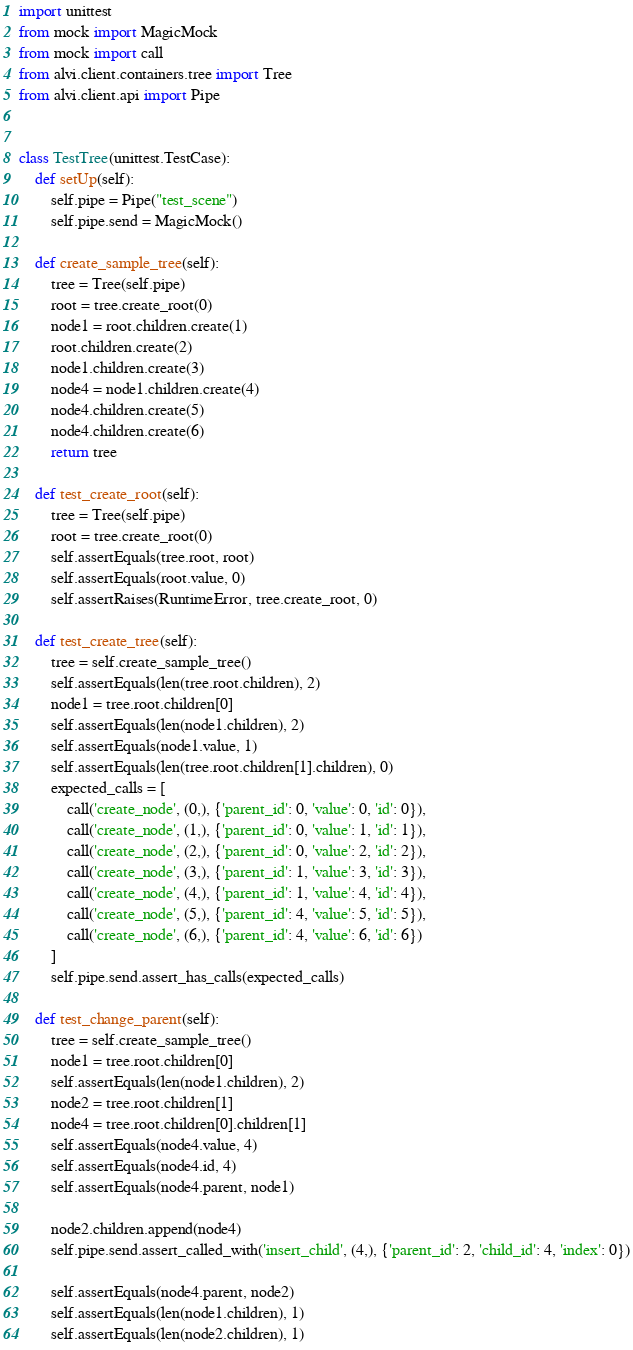<code> <loc_0><loc_0><loc_500><loc_500><_Python_>import unittest
from mock import MagicMock
from mock import call
from alvi.client.containers.tree import Tree
from alvi.client.api import Pipe


class TestTree(unittest.TestCase):
    def setUp(self):
        self.pipe = Pipe("test_scene")
        self.pipe.send = MagicMock()

    def create_sample_tree(self):
        tree = Tree(self.pipe)
        root = tree.create_root(0)
        node1 = root.children.create(1)
        root.children.create(2)
        node1.children.create(3)
        node4 = node1.children.create(4)
        node4.children.create(5)
        node4.children.create(6)
        return tree

    def test_create_root(self):
        tree = Tree(self.pipe)
        root = tree.create_root(0)
        self.assertEquals(tree.root, root)
        self.assertEquals(root.value, 0)
        self.assertRaises(RuntimeError, tree.create_root, 0)

    def test_create_tree(self):
        tree = self.create_sample_tree()
        self.assertEquals(len(tree.root.children), 2)
        node1 = tree.root.children[0]
        self.assertEquals(len(node1.children), 2)
        self.assertEquals(node1.value, 1)
        self.assertEquals(len(tree.root.children[1].children), 0)
        expected_calls = [
            call('create_node', (0,), {'parent_id': 0, 'value': 0, 'id': 0}),
            call('create_node', (1,), {'parent_id': 0, 'value': 1, 'id': 1}),
            call('create_node', (2,), {'parent_id': 0, 'value': 2, 'id': 2}),
            call('create_node', (3,), {'parent_id': 1, 'value': 3, 'id': 3}),
            call('create_node', (4,), {'parent_id': 1, 'value': 4, 'id': 4}),
            call('create_node', (5,), {'parent_id': 4, 'value': 5, 'id': 5}),
            call('create_node', (6,), {'parent_id': 4, 'value': 6, 'id': 6})
        ]
        self.pipe.send.assert_has_calls(expected_calls)

    def test_change_parent(self):
        tree = self.create_sample_tree()
        node1 = tree.root.children[0]
        self.assertEquals(len(node1.children), 2)
        node2 = tree.root.children[1]
        node4 = tree.root.children[0].children[1]
        self.assertEquals(node4.value, 4)
        self.assertEquals(node4.id, 4)
        self.assertEquals(node4.parent, node1)

        node2.children.append(node4)
        self.pipe.send.assert_called_with('insert_child', (4,), {'parent_id': 2, 'child_id': 4, 'index': 0})

        self.assertEquals(node4.parent, node2)
        self.assertEquals(len(node1.children), 1)
        self.assertEquals(len(node2.children), 1)</code> 